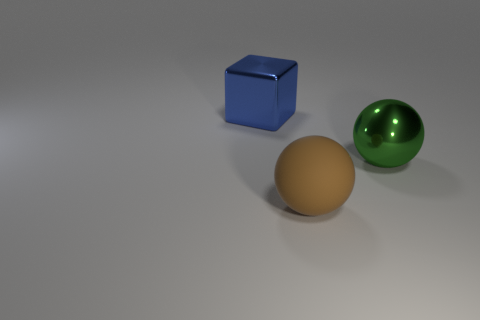Can you describe the objects in the image regarding their shapes and colors? Certainly! In the image, there are three objects with distinct shapes and colors. There is a blue cube that has a shiny surface, a large green sphere that appears to have a reflective metal finish, and a matte brown sphere that looks less reflective compared to the green one. 